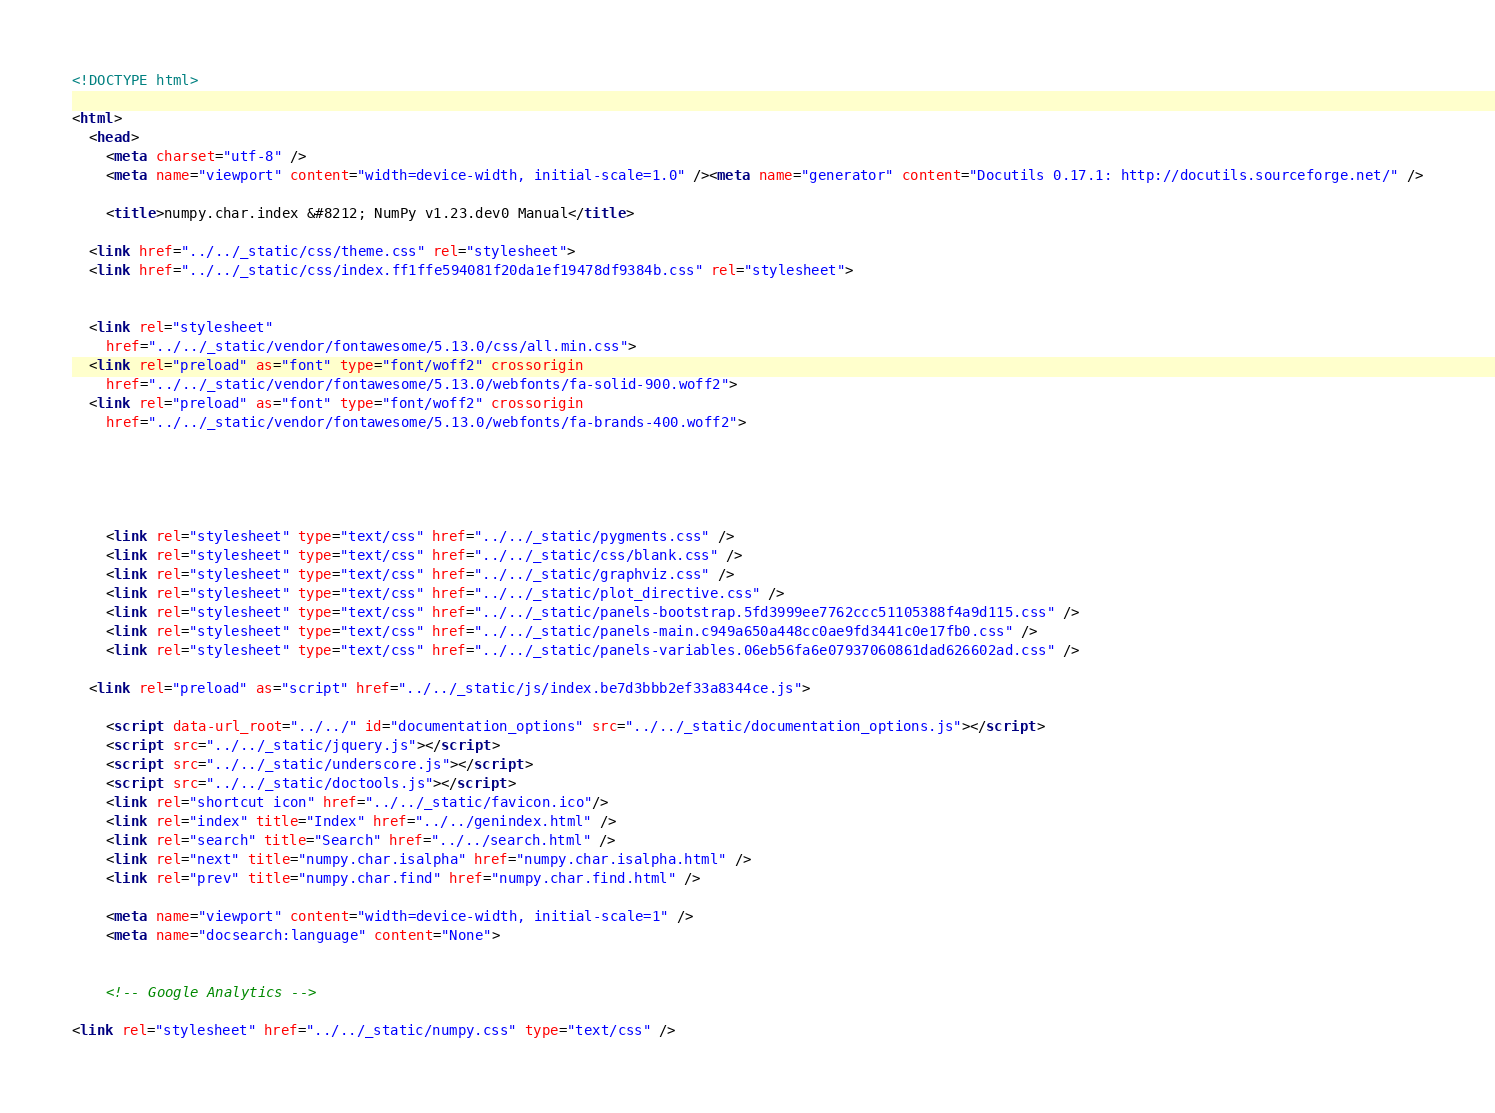Convert code to text. <code><loc_0><loc_0><loc_500><loc_500><_HTML_>
<!DOCTYPE html>

<html>
  <head>
    <meta charset="utf-8" />
    <meta name="viewport" content="width=device-width, initial-scale=1.0" /><meta name="generator" content="Docutils 0.17.1: http://docutils.sourceforge.net/" />

    <title>numpy.char.index &#8212; NumPy v1.23.dev0 Manual</title>
    
  <link href="../../_static/css/theme.css" rel="stylesheet">
  <link href="../../_static/css/index.ff1ffe594081f20da1ef19478df9384b.css" rel="stylesheet">

    
  <link rel="stylesheet"
    href="../../_static/vendor/fontawesome/5.13.0/css/all.min.css">
  <link rel="preload" as="font" type="font/woff2" crossorigin
    href="../../_static/vendor/fontawesome/5.13.0/webfonts/fa-solid-900.woff2">
  <link rel="preload" as="font" type="font/woff2" crossorigin
    href="../../_static/vendor/fontawesome/5.13.0/webfonts/fa-brands-400.woff2">

    
      

    
    <link rel="stylesheet" type="text/css" href="../../_static/pygments.css" />
    <link rel="stylesheet" type="text/css" href="../../_static/css/blank.css" />
    <link rel="stylesheet" type="text/css" href="../../_static/graphviz.css" />
    <link rel="stylesheet" type="text/css" href="../../_static/plot_directive.css" />
    <link rel="stylesheet" type="text/css" href="../../_static/panels-bootstrap.5fd3999ee7762ccc51105388f4a9d115.css" />
    <link rel="stylesheet" type="text/css" href="../../_static/panels-main.c949a650a448cc0ae9fd3441c0e17fb0.css" />
    <link rel="stylesheet" type="text/css" href="../../_static/panels-variables.06eb56fa6e07937060861dad626602ad.css" />
    
  <link rel="preload" as="script" href="../../_static/js/index.be7d3bbb2ef33a8344ce.js">

    <script data-url_root="../../" id="documentation_options" src="../../_static/documentation_options.js"></script>
    <script src="../../_static/jquery.js"></script>
    <script src="../../_static/underscore.js"></script>
    <script src="../../_static/doctools.js"></script>
    <link rel="shortcut icon" href="../../_static/favicon.ico"/>
    <link rel="index" title="Index" href="../../genindex.html" />
    <link rel="search" title="Search" href="../../search.html" />
    <link rel="next" title="numpy.char.isalpha" href="numpy.char.isalpha.html" />
    <link rel="prev" title="numpy.char.find" href="numpy.char.find.html" />

    <meta name="viewport" content="width=device-width, initial-scale=1" />
    <meta name="docsearch:language" content="None">
    

    <!-- Google Analytics -->
    
<link rel="stylesheet" href="../../_static/numpy.css" type="text/css" />
</code> 